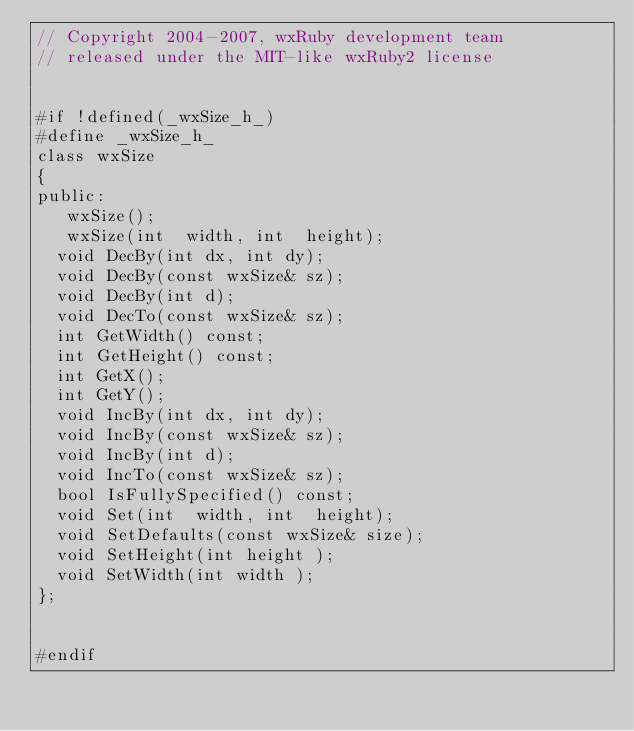<code> <loc_0><loc_0><loc_500><loc_500><_C_>// Copyright 2004-2007, wxRuby development team
// released under the MIT-like wxRuby2 license


#if !defined(_wxSize_h_)
#define _wxSize_h_
class wxSize
{
public:
   wxSize();
   wxSize(int  width, int  height);
  void DecBy(int dx, int dy);
  void DecBy(const wxSize& sz);
  void DecBy(int d);
  void DecTo(const wxSize& sz);
  int GetWidth() const;
  int GetHeight() const;    
  int GetX();
  int GetY();
  void IncBy(int dx, int dy);
  void IncBy(const wxSize& sz);
  void IncBy(int d);
  void IncTo(const wxSize& sz);
  bool IsFullySpecified() const;
  void Set(int  width, int  height);
  void SetDefaults(const wxSize& size);
  void SetHeight(int height );
  void SetWidth(int width );
};


#endif
</code> 